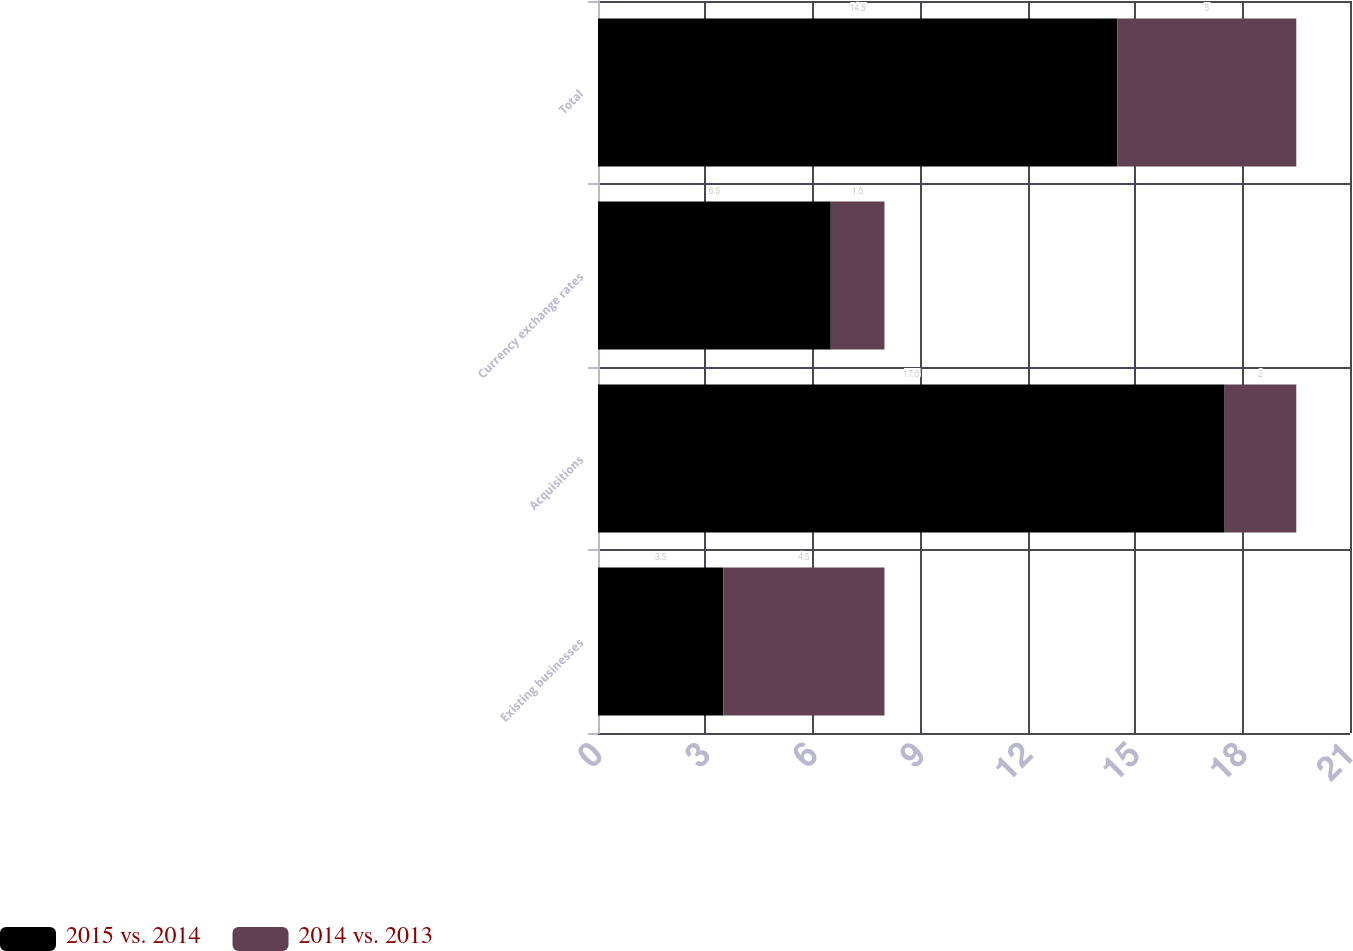<chart> <loc_0><loc_0><loc_500><loc_500><stacked_bar_chart><ecel><fcel>Existing businesses<fcel>Acquisitions<fcel>Currency exchange rates<fcel>Total<nl><fcel>2015 vs. 2014<fcel>3.5<fcel>17.5<fcel>6.5<fcel>14.5<nl><fcel>2014 vs. 2013<fcel>4.5<fcel>2<fcel>1.5<fcel>5<nl></chart> 